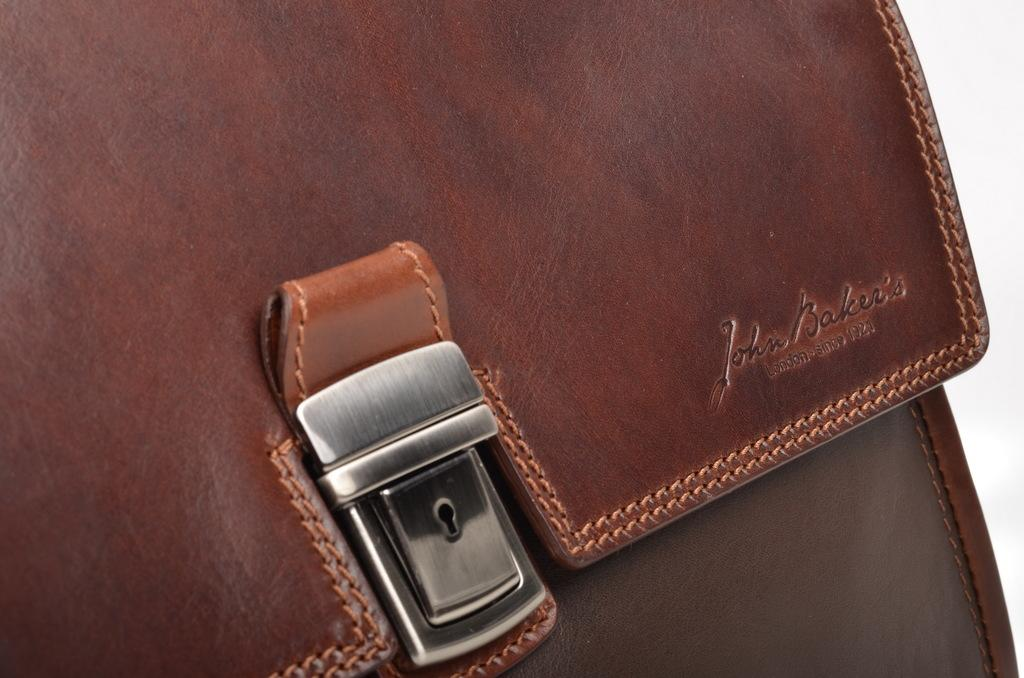What object can be seen in the image? There is a bag in the image. What is the son's reaction to the bag in the image? There is no son present in the image, so it is not possible to determine their reaction to the bag. 